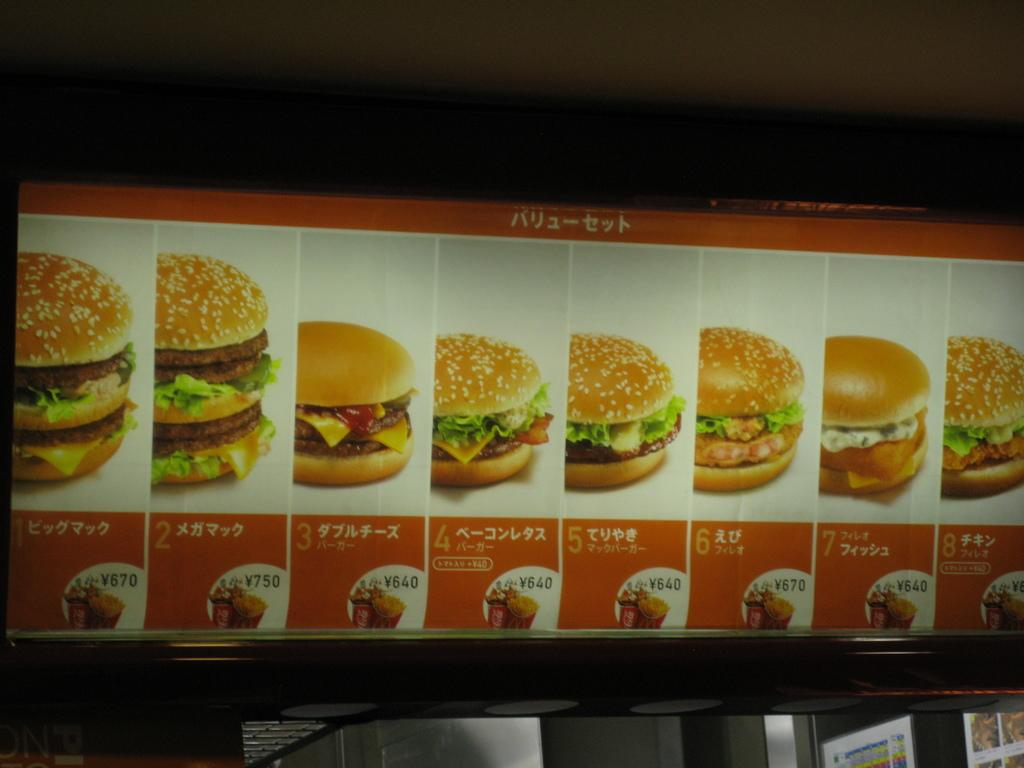What is depicted on the main poster in the image? There is a poster with images of burgers in the image. How can you tell the price of the burgers? The price is edited on the poster. Are there any other posters visible in the image? Yes, there are additional posters attached to the wall at the bottom of the image. What type of science experiment is being conducted with the leg in the image? There is no leg or science experiment present in the image. Can you tell me how many pears are on the poster with the burgers? There are no pears depicted on the poster with the burgers; it only features images of burgers. 